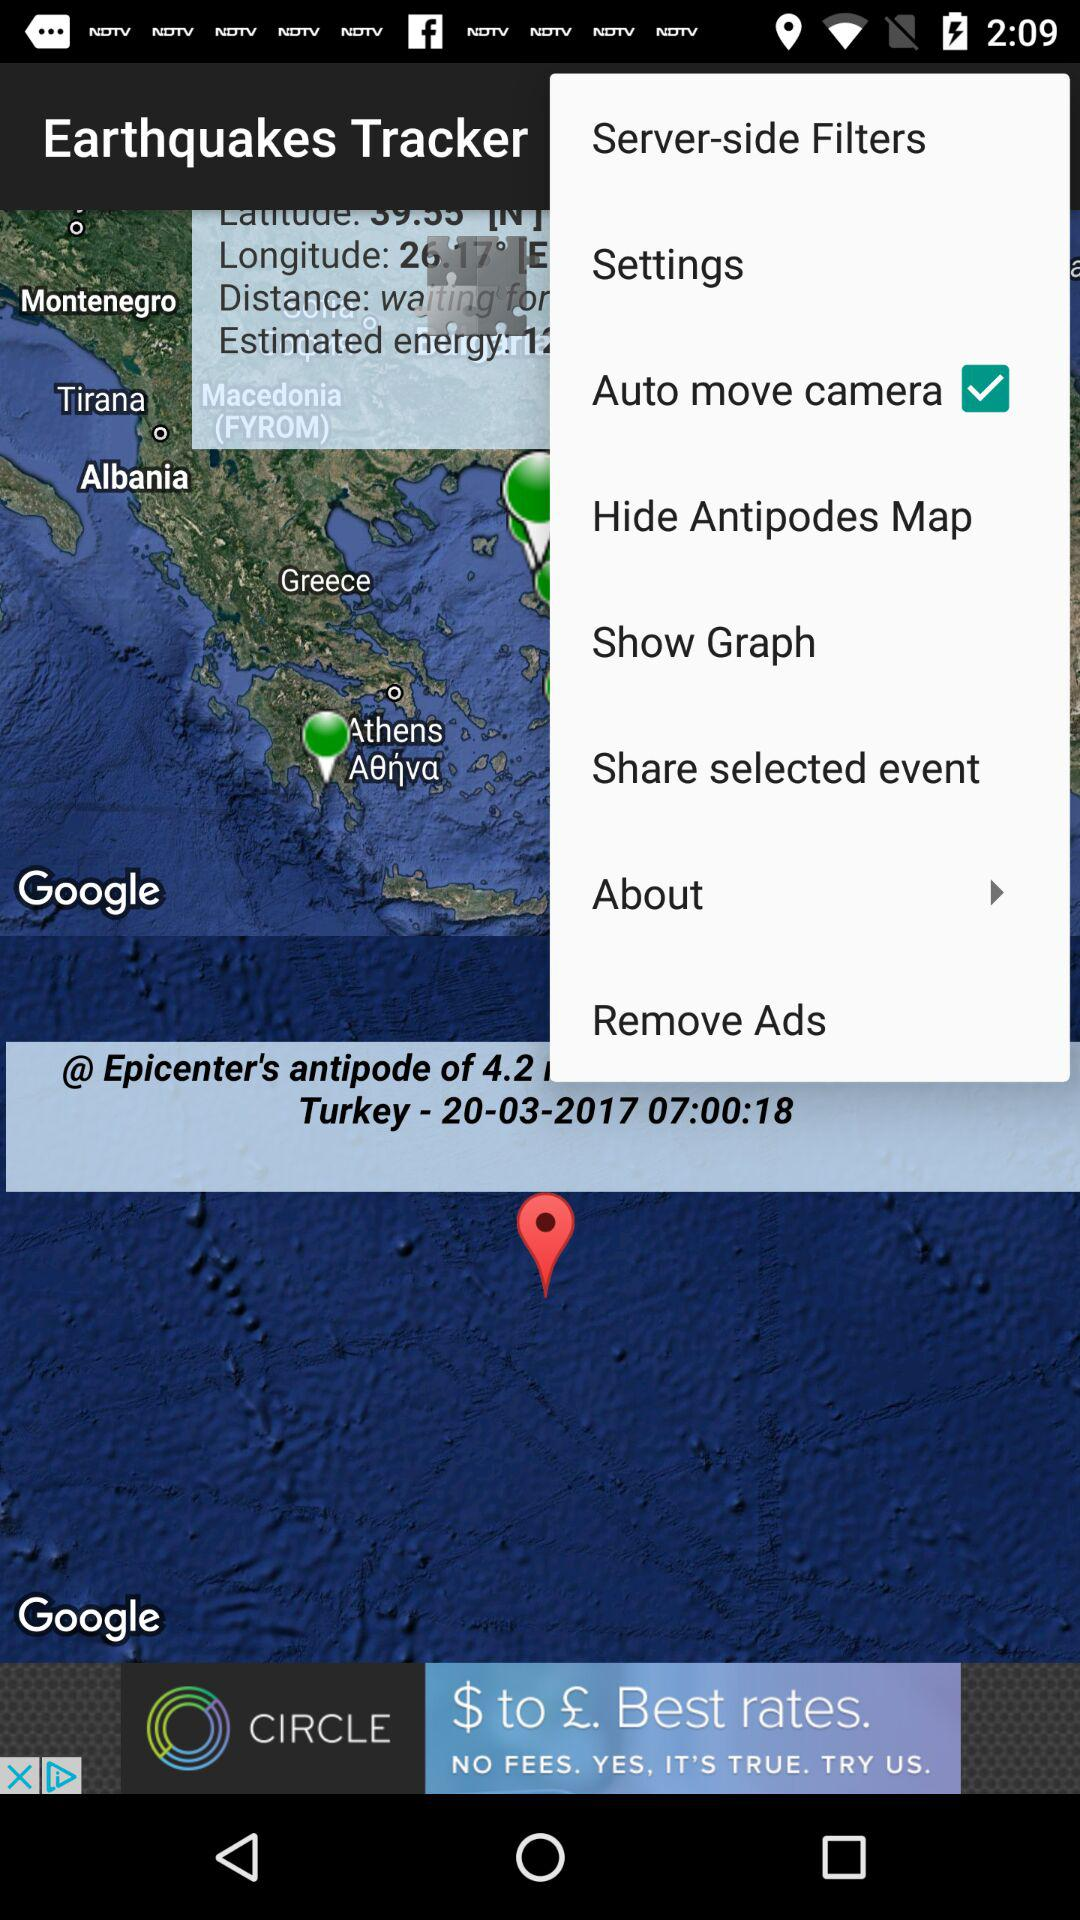Which country is mentioned? The country mentioned is Turkey. 